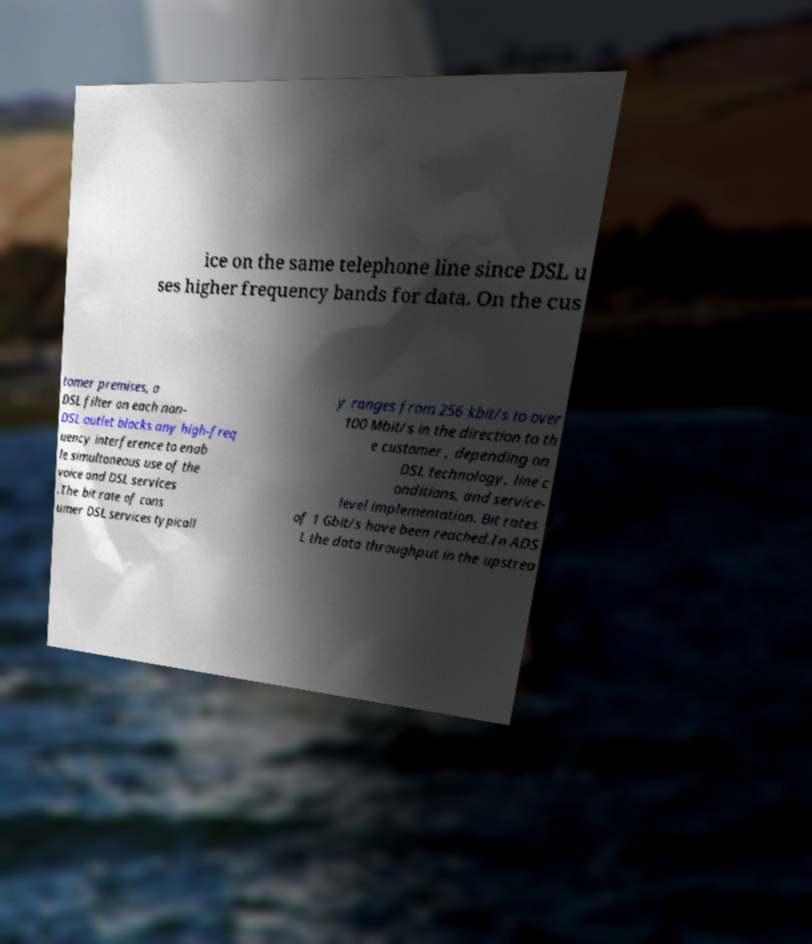Can you accurately transcribe the text from the provided image for me? ice on the same telephone line since DSL u ses higher frequency bands for data. On the cus tomer premises, a DSL filter on each non- DSL outlet blocks any high-freq uency interference to enab le simultaneous use of the voice and DSL services .The bit rate of cons umer DSL services typicall y ranges from 256 kbit/s to over 100 Mbit/s in the direction to th e customer , depending on DSL technology, line c onditions, and service- level implementation. Bit rates of 1 Gbit/s have been reached.In ADS L the data throughput in the upstrea 